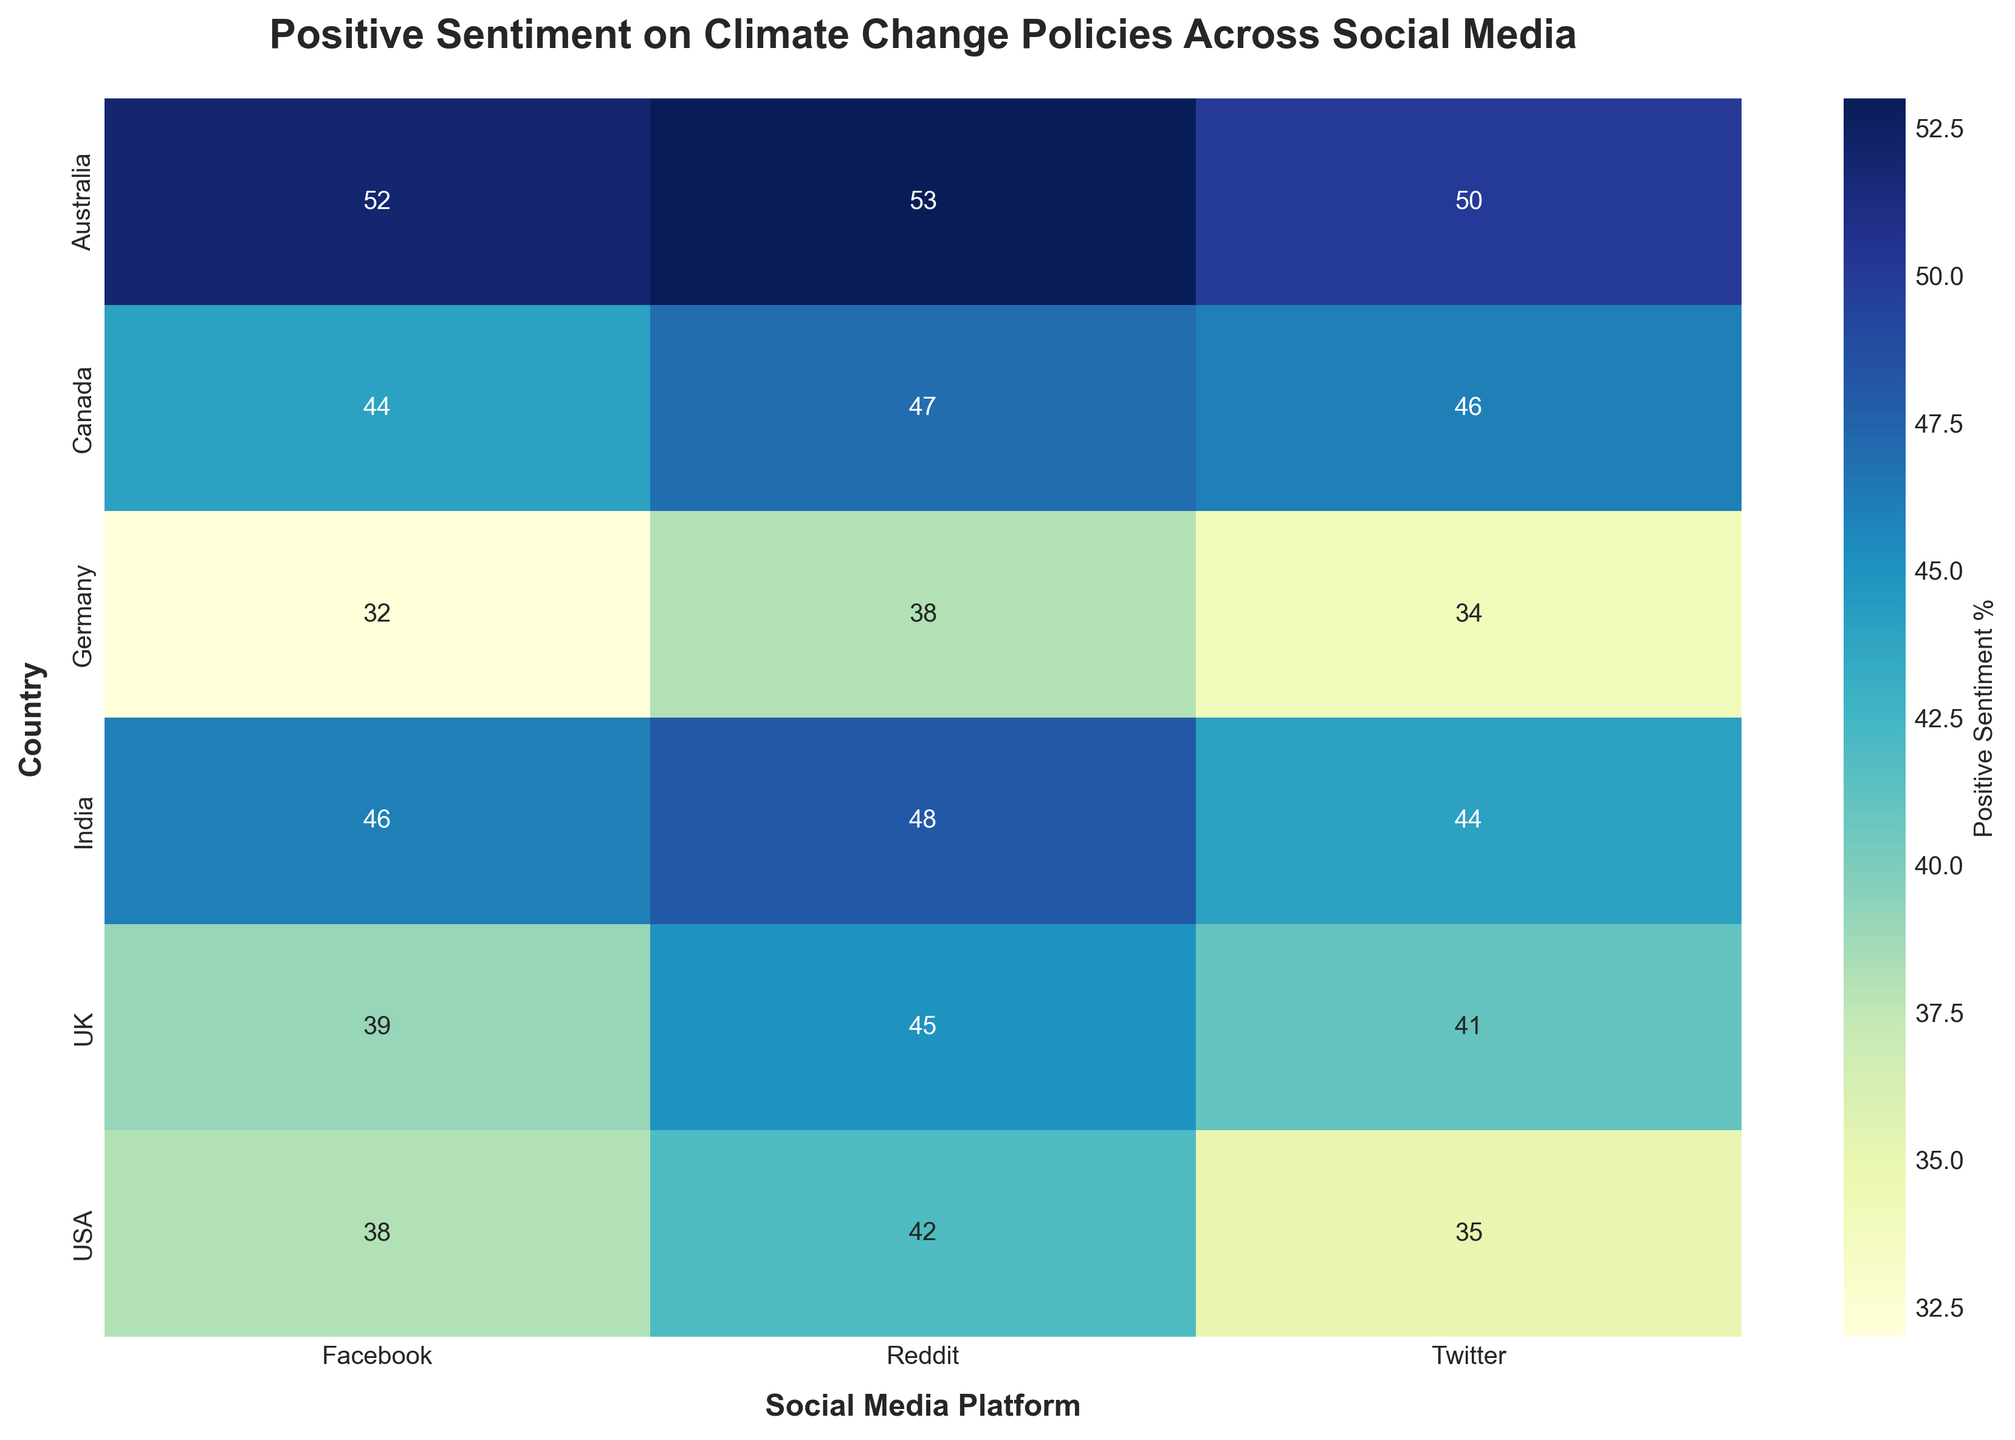what is the highest positive sentiment percentage observed in the heatmap? To find the highest positive sentiment percentage, look at all the cells of the heatmap and identify the maximum value. The highest value is 53.
Answer: 53 which country has the lowest positive sentiment on Twitter? Locate the Twitter column and identify the countries with their corresponding values. The lowest sentiment is 34 for Germany.
Answer: Germany what is the average positive sentiment percentage on Reddit for all the countries? Add the positive sentiment percentages on Reddit for all the countries (42, 47, 45, 38, 53, 48), then divide by the number of values (6). (42 + 47 + 45 + 38 + 53 + 48)/6 = 45.5
Answer: 45.5 which country shows the most uniform positive sentiment across all platforms? Check each country’s values across Twitter, Facebook, and Reddit to identify which country has the least variation in its sentiment values. The USA has values that are relatively close - Twitter: 35, Facebook: 38, Reddit: 42.
Answer: USA how does Australia's positive sentiment on Facebook compare with other countries? Examine Australia's positive sentiment on Facebook, which is 52, and compare it to the values from other countries. Australia has the highest compared to the other countries in the heatmap.
Answer: highest what is the difference between the highest and lowest positive sentiment percentages on Twitter? Identify the highest positive sentiment percentage on Twitter (50 for Australia) and the lowest (34 for Germany) and calculate the difference. 50 - 34 = 16
Answer: 16 which social media platform generally has the highest positive sentiment percentages? Compare the average positive sentiment percentages for Twitter, Facebook, and Reddit across all countries. Reddit generally has higher percentages.
Answer: Reddit what is the total positive sentiment for the UK across all platforms? Add the positive sentiment percentages for Twitter, Facebook, and Reddit for the UK. 41 + 39 + 45 = 125
Answer: 125 which country’s positive sentiment is consistently above 40 across all platforms? Check each country's values for Twitter, Facebook, and Reddit, and identify which country has all values above 40. Canada has values 46, 44, 47.
Answer: Canada 